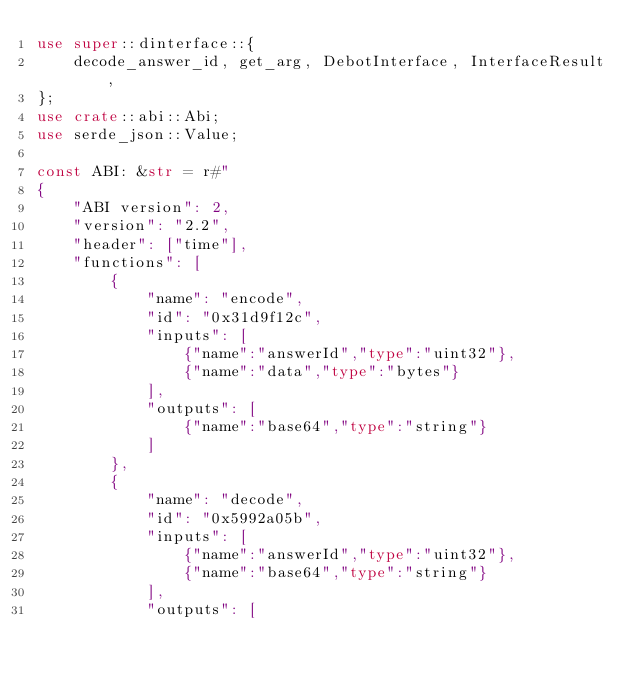<code> <loc_0><loc_0><loc_500><loc_500><_Rust_>use super::dinterface::{
    decode_answer_id, get_arg, DebotInterface, InterfaceResult,
};
use crate::abi::Abi;
use serde_json::Value;

const ABI: &str = r#"
{
	"ABI version": 2,
	"version": "2.2",
	"header": ["time"],
	"functions": [
		{
			"name": "encode",
			"id": "0x31d9f12c",
			"inputs": [
				{"name":"answerId","type":"uint32"},
				{"name":"data","type":"bytes"}
			],
			"outputs": [
				{"name":"base64","type":"string"}
			]
		},
		{
			"name": "decode",
			"id": "0x5992a05b",
			"inputs": [
				{"name":"answerId","type":"uint32"},
				{"name":"base64","type":"string"}
			],
			"outputs": [</code> 